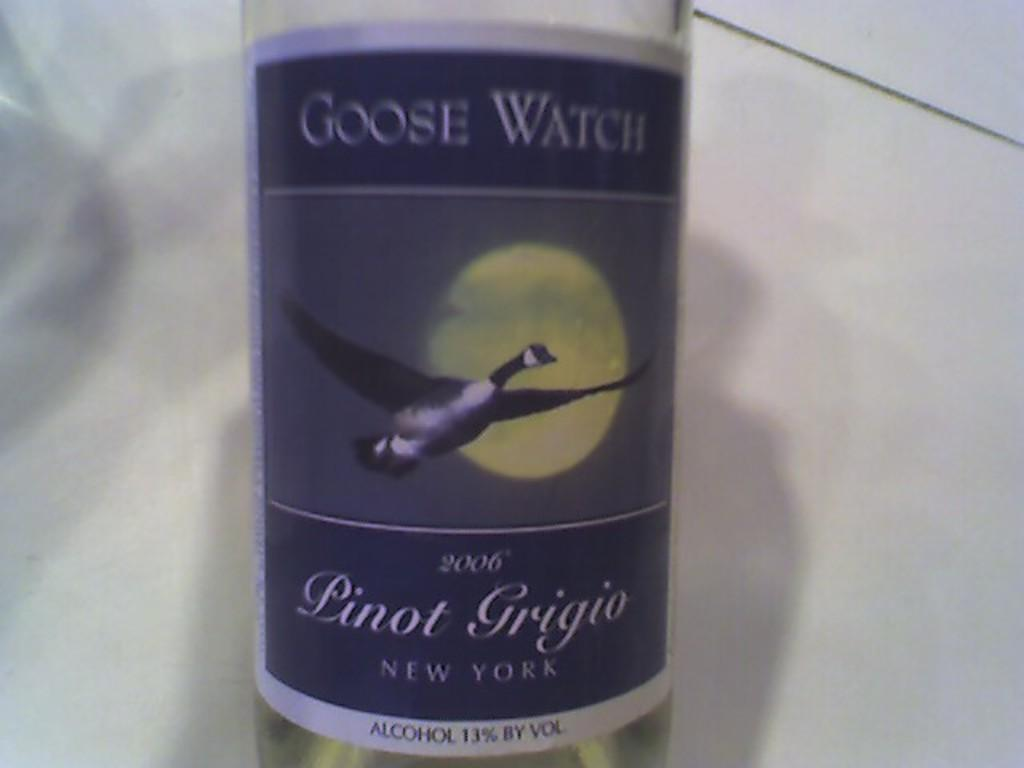<image>
Relay a brief, clear account of the picture shown. A bottle of Linot Grigio New York alcohol 